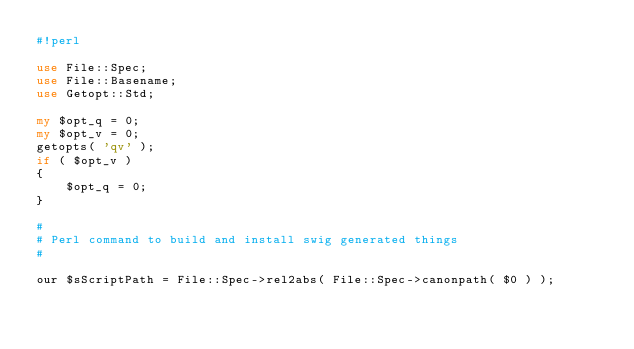Convert code to text. <code><loc_0><loc_0><loc_500><loc_500><_Perl_>#!perl

use File::Spec;
use File::Basename;
use Getopt::Std;

my $opt_q = 0;
my $opt_v = 0;
getopts( 'qv' );
if ( $opt_v )
{
	$opt_q = 0;
}

#
# Perl command to build and install swig generated things
#

our $sScriptPath = File::Spec->rel2abs( File::Spec->canonpath( $0 ) );</code> 